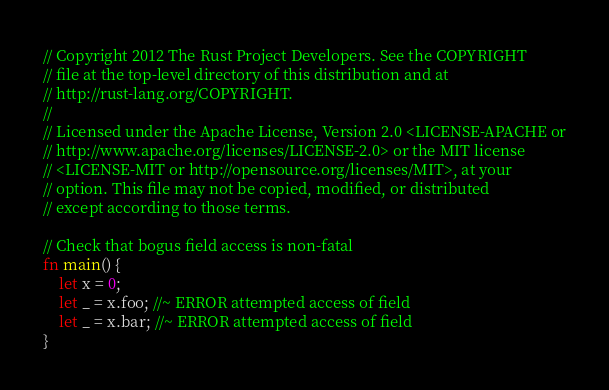Convert code to text. <code><loc_0><loc_0><loc_500><loc_500><_Rust_>// Copyright 2012 The Rust Project Developers. See the COPYRIGHT
// file at the top-level directory of this distribution and at
// http://rust-lang.org/COPYRIGHT.
//
// Licensed under the Apache License, Version 2.0 <LICENSE-APACHE or
// http://www.apache.org/licenses/LICENSE-2.0> or the MIT license
// <LICENSE-MIT or http://opensource.org/licenses/MIT>, at your
// option. This file may not be copied, modified, or distributed
// except according to those terms.

// Check that bogus field access is non-fatal
fn main() {
    let x = 0;
    let _ = x.foo; //~ ERROR attempted access of field
    let _ = x.bar; //~ ERROR attempted access of field
}
</code> 